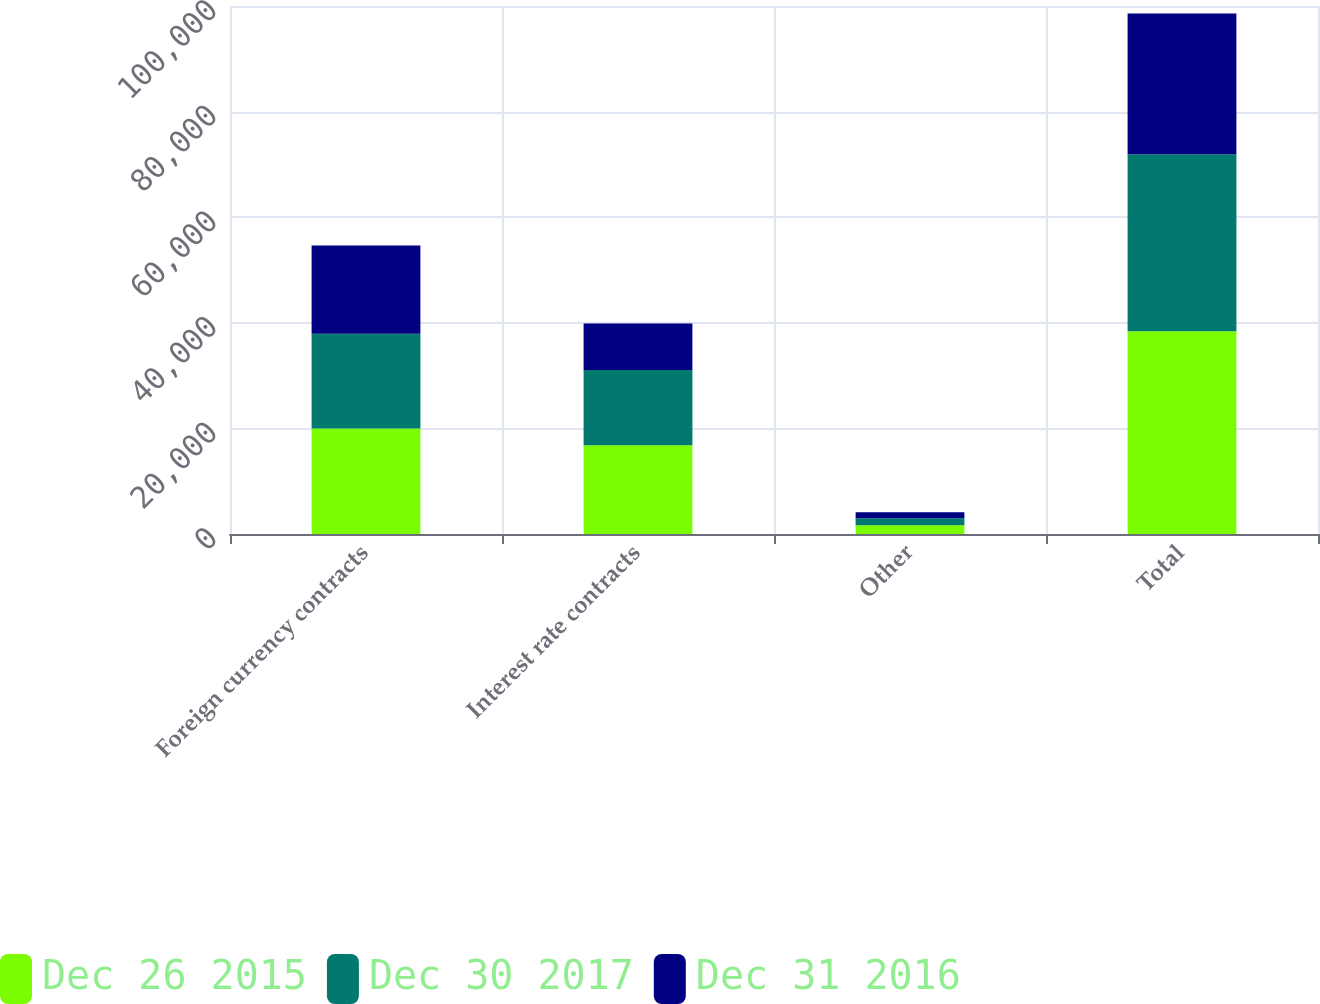Convert chart to OTSL. <chart><loc_0><loc_0><loc_500><loc_500><stacked_bar_chart><ecel><fcel>Foreign currency contracts<fcel>Interest rate contracts<fcel>Other<fcel>Total<nl><fcel>Dec 26 2015<fcel>19958<fcel>16823<fcel>1636<fcel>38417<nl><fcel>Dec 30 2017<fcel>17960<fcel>14228<fcel>1340<fcel>33528<nl><fcel>Dec 31 2016<fcel>16721<fcel>8812<fcel>1122<fcel>26655<nl></chart> 